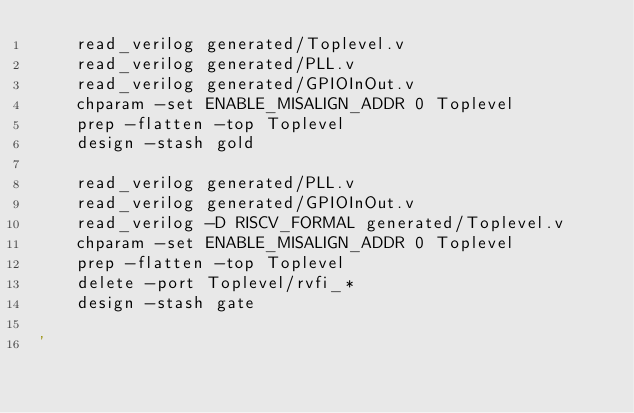Convert code to text. <code><loc_0><loc_0><loc_500><loc_500><_Bash_>	read_verilog generated/Toplevel.v
	read_verilog generated/PLL.v
	read_verilog generated/GPIOInOut.v
	chparam -set ENABLE_MISALIGN_ADDR 0 Toplevel
	prep -flatten -top Toplevel
	design -stash gold

	read_verilog generated/PLL.v
	read_verilog generated/GPIOInOut.v
	read_verilog -D RISCV_FORMAL generated/Toplevel.v
	chparam -set ENABLE_MISALIGN_ADDR 0 Toplevel
	prep -flatten -top Toplevel
	delete -port Toplevel/rvfi_*
	design -stash gate

'
</code> 